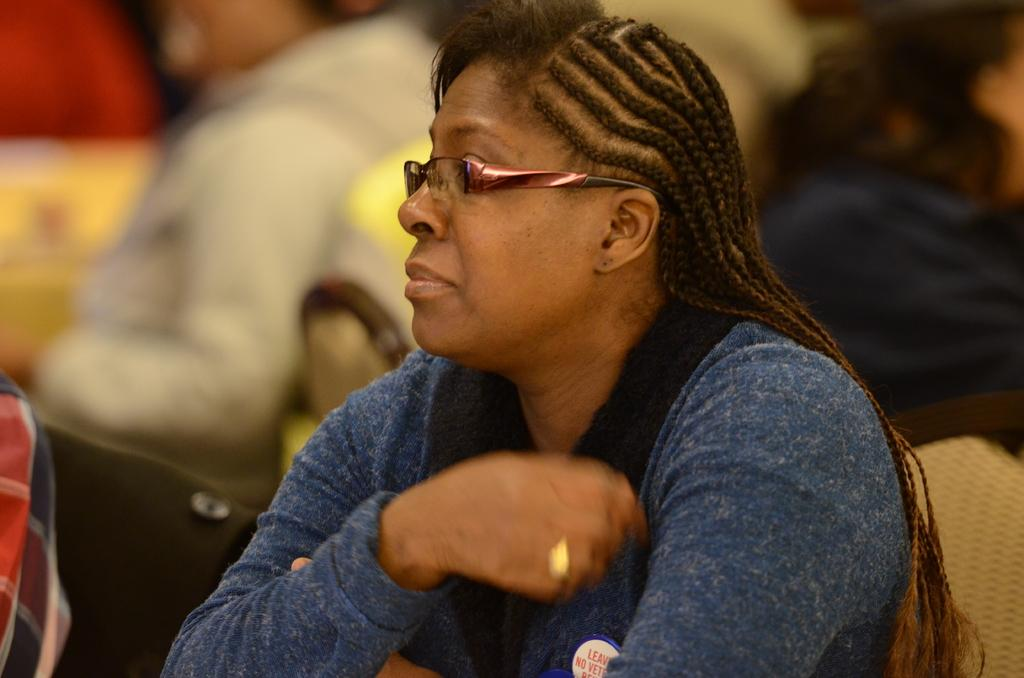What is the woman in the image doing? The woman is sitting on a chair in the image. Can you describe the background of the image? In the background, there are persons sitting on chairs. However, the image is blurred, so we cannot provide more specific details about the background persons. What type of fruit is the woman holding in the image? There is no fruit present in the image; the woman is sitting on a chair without holding any objects. 